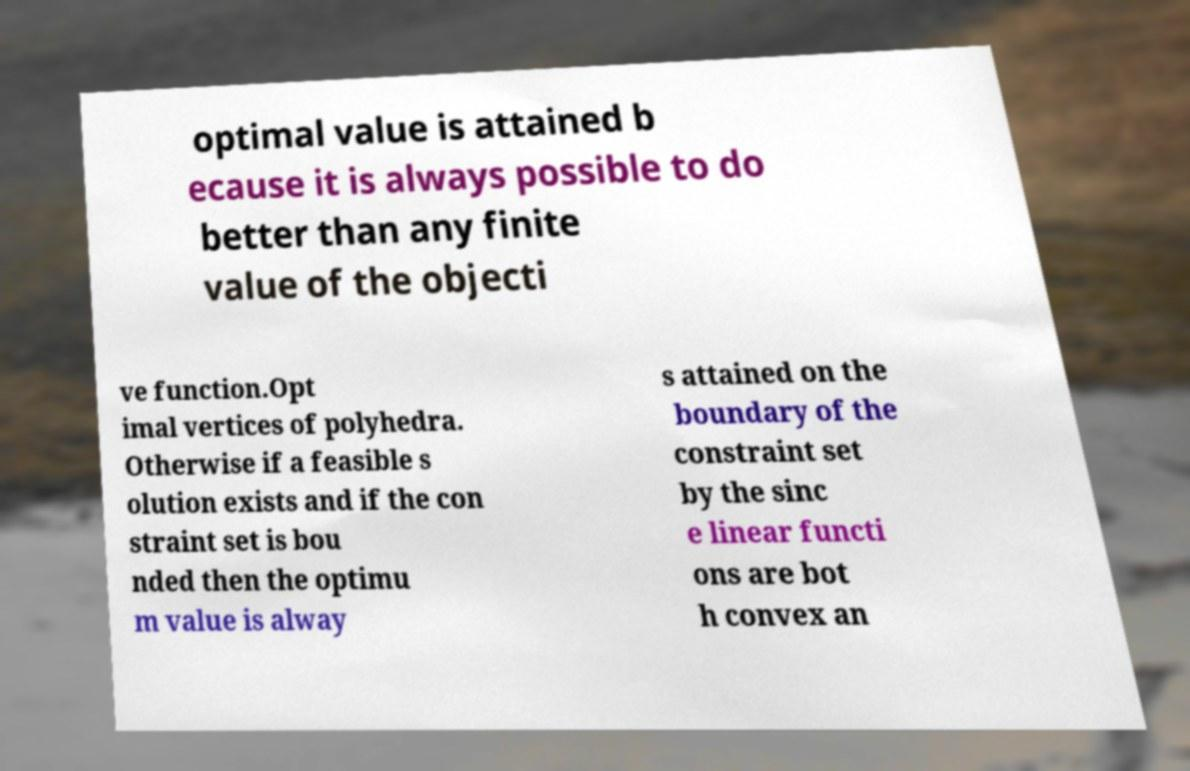I need the written content from this picture converted into text. Can you do that? optimal value is attained b ecause it is always possible to do better than any finite value of the objecti ve function.Opt imal vertices of polyhedra. Otherwise if a feasible s olution exists and if the con straint set is bou nded then the optimu m value is alway s attained on the boundary of the constraint set by the sinc e linear functi ons are bot h convex an 